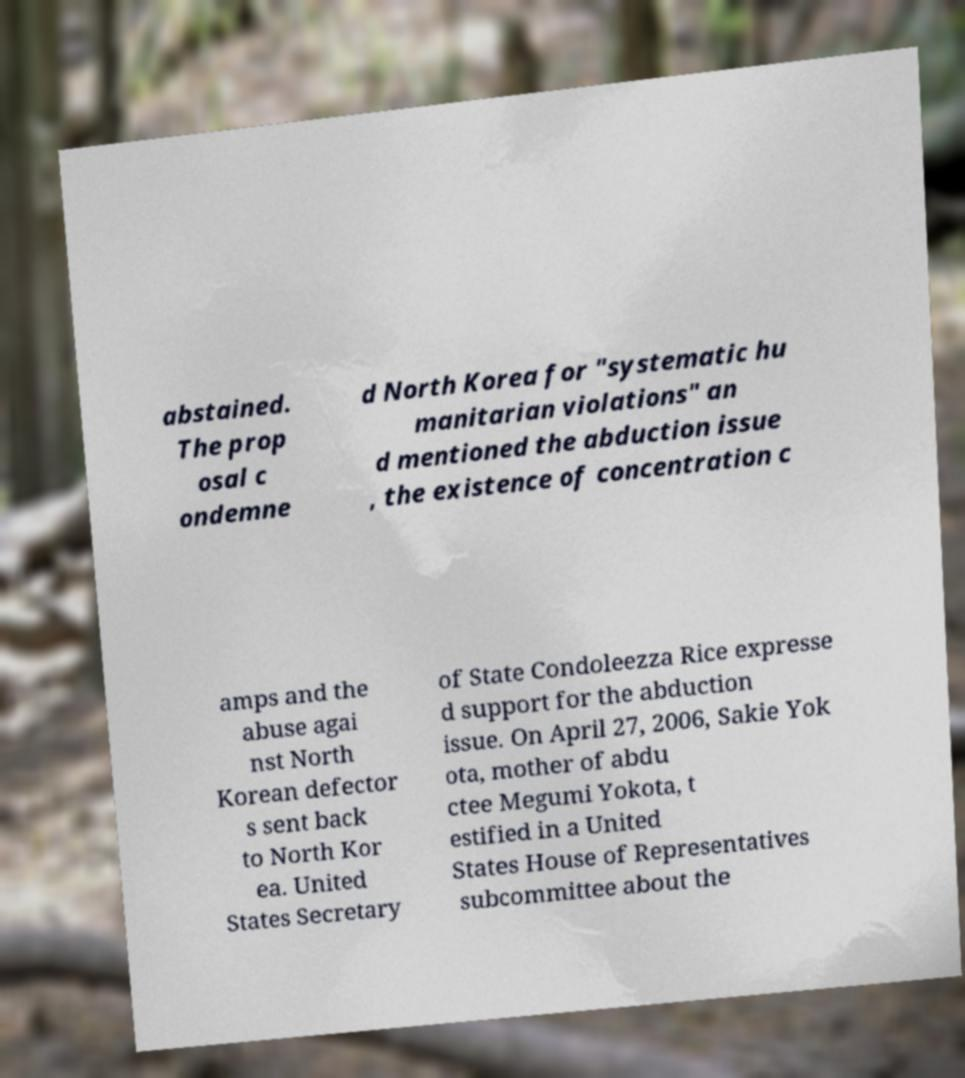Could you extract and type out the text from this image? abstained. The prop osal c ondemne d North Korea for "systematic hu manitarian violations" an d mentioned the abduction issue , the existence of concentration c amps and the abuse agai nst North Korean defector s sent back to North Kor ea. United States Secretary of State Condoleezza Rice expresse d support for the abduction issue. On April 27, 2006, Sakie Yok ota, mother of abdu ctee Megumi Yokota, t estified in a United States House of Representatives subcommittee about the 